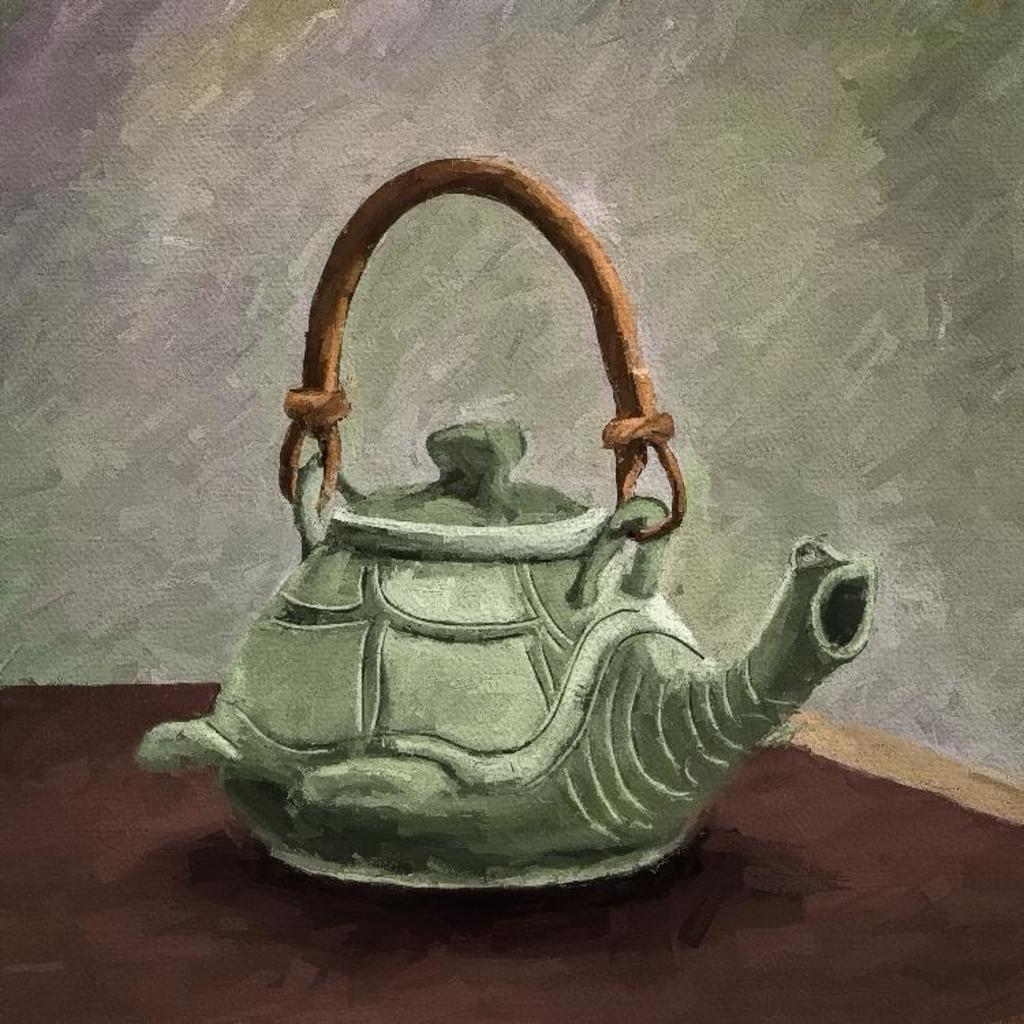What is the main subject of the image? There is a painting in the image. What does the painting depict? The painting depicts coffee cattle. Where are the scissors located in the image? There are no scissors present in the image; it only features a painting of coffee cattle. 